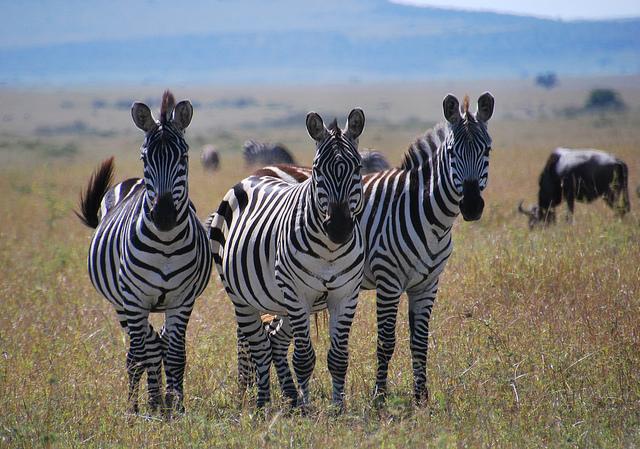How many different types of animals are in the picture?
Answer briefly. 2. Is the zebra in the middle young?
Short answer required. No. Is the middle zebra pregnant?
Answer briefly. No. How many zebras are facing the camera?
Concise answer only. 3. How many zebras?
Concise answer only. 3. How many stripes are on the zebras?
Concise answer only. 100. Are any zebras eating?
Answer briefly. No. How many zebras are facing forward?
Write a very short answer. 3. How many animals are in the background?
Write a very short answer. 4. Are the animals in a zoo?
Write a very short answer. No. Is one zebra larger than the others?
Keep it brief. No. How many zebras are pictured?
Quick response, please. 3. 